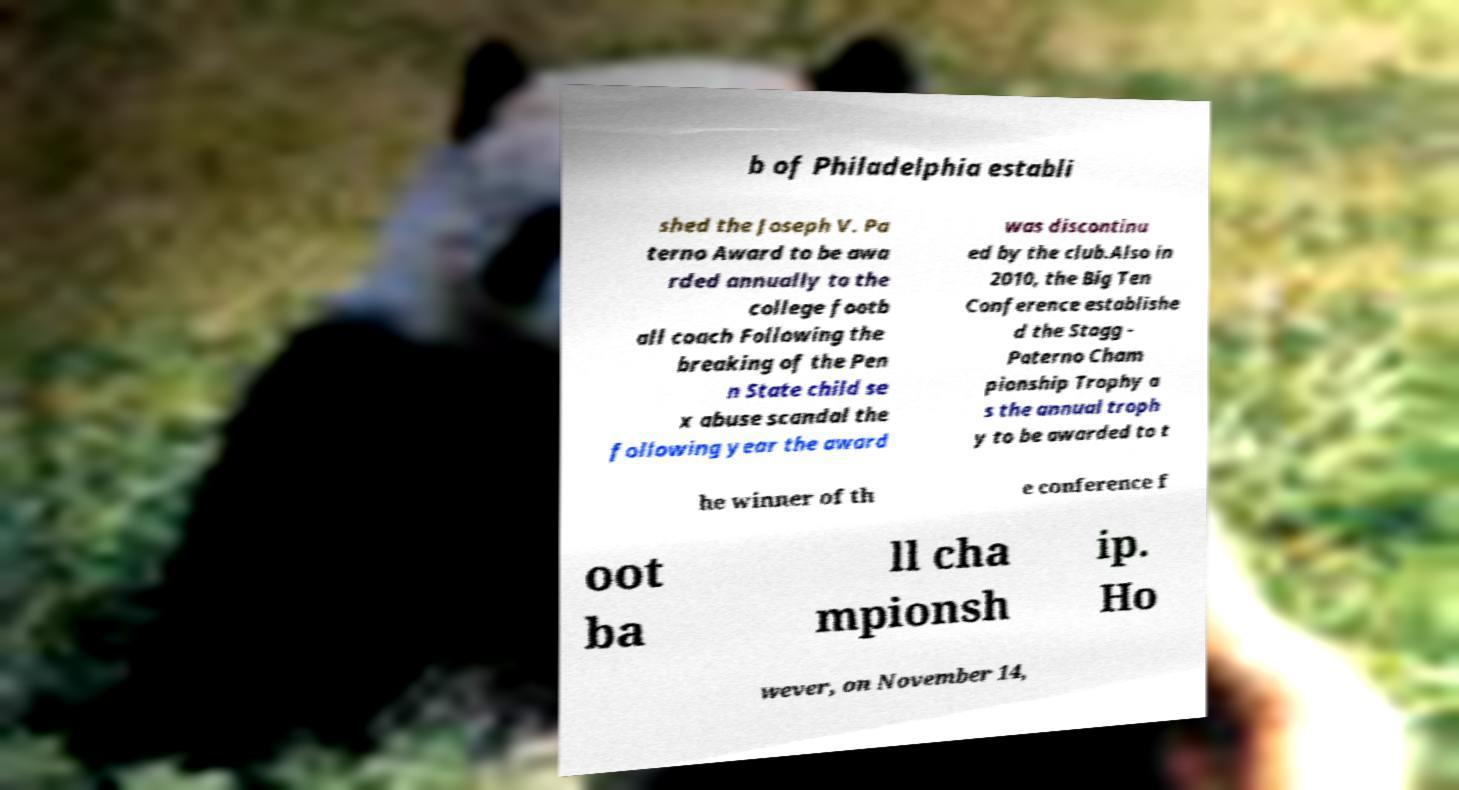Please read and relay the text visible in this image. What does it say? b of Philadelphia establi shed the Joseph V. Pa terno Award to be awa rded annually to the college footb all coach Following the breaking of the Pen n State child se x abuse scandal the following year the award was discontinu ed by the club.Also in 2010, the Big Ten Conference establishe d the Stagg - Paterno Cham pionship Trophy a s the annual troph y to be awarded to t he winner of th e conference f oot ba ll cha mpionsh ip. Ho wever, on November 14, 